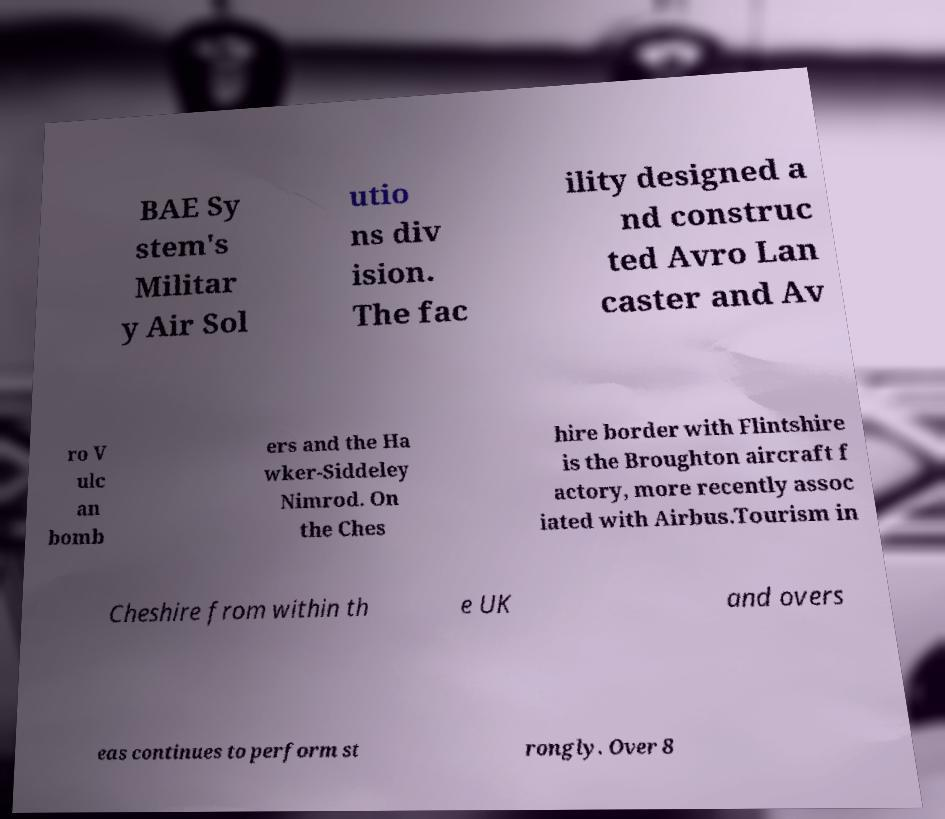Can you read and provide the text displayed in the image?This photo seems to have some interesting text. Can you extract and type it out for me? BAE Sy stem's Militar y Air Sol utio ns div ision. The fac ility designed a nd construc ted Avro Lan caster and Av ro V ulc an bomb ers and the Ha wker-Siddeley Nimrod. On the Ches hire border with Flintshire is the Broughton aircraft f actory, more recently assoc iated with Airbus.Tourism in Cheshire from within th e UK and overs eas continues to perform st rongly. Over 8 